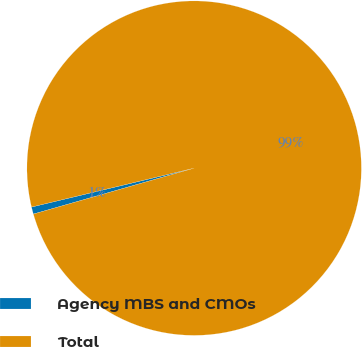<chart> <loc_0><loc_0><loc_500><loc_500><pie_chart><fcel>Agency MBS and CMOs<fcel>Total<nl><fcel>0.69%<fcel>99.31%<nl></chart> 